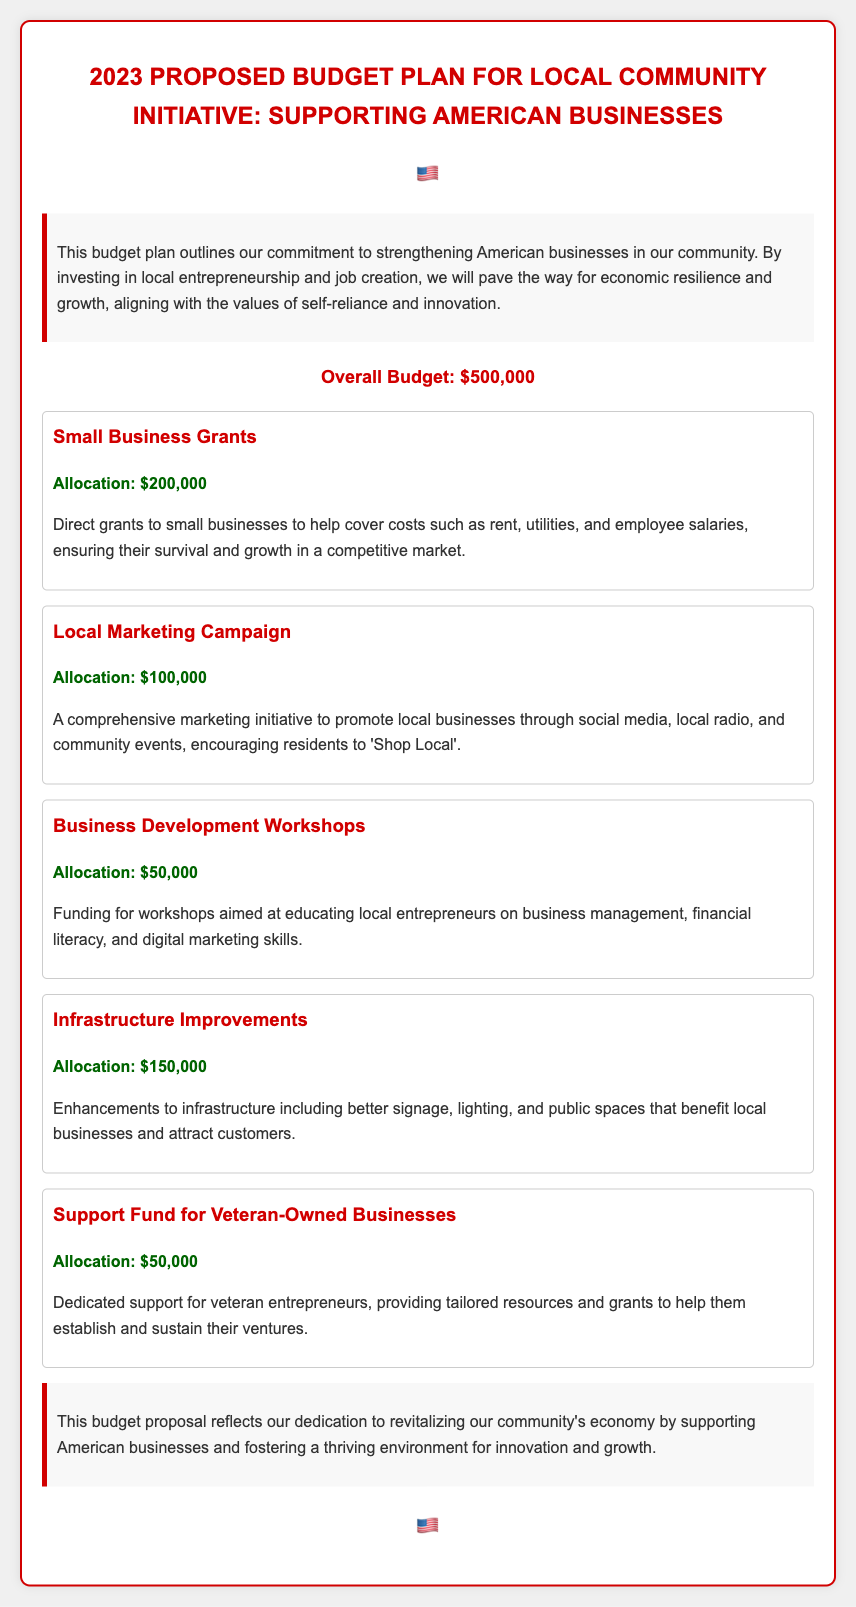What is the total budget for the initiative? The total budget for the initiative is clearly stated in the document.
Answer: $500,000 What is the allocation for Small Business Grants? The document specifies the allocation for Small Business Grants clearly.
Answer: $200,000 How much is allocated to the Local Marketing Campaign? The allocation for the Local Marketing Campaign can be found within the allocations section.
Answer: $100,000 What is the purpose of the Business Development Workshops? The purpose of these workshops is explained in detail in the document.
Answer: Educating local entrepreneurs What is the allocation for the Support Fund for Veteran-Owned Businesses? The specific allocation for the Support Fund for Veteran-Owned Businesses is mentioned in the budget.
Answer: $50,000 Which initiative has the highest funding? The document compares allocations of various initiatives, identifying the one with the highest funding.
Answer: Small Business Grants What portion of the budget is dedicated to Infrastructure Improvements? The document lists the specific allocation for Infrastructure Improvements, allowing for easy retrieval.
Answer: $150,000 What does the overall budget aim to do for American businesses? The document outlines the overall aim of the proposed budget in relation to American businesses.
Answer: Strengthening American businesses How many different categories are there in the allocation? The document lists various allocations which can be counted to determine the number of categories.
Answer: Five 